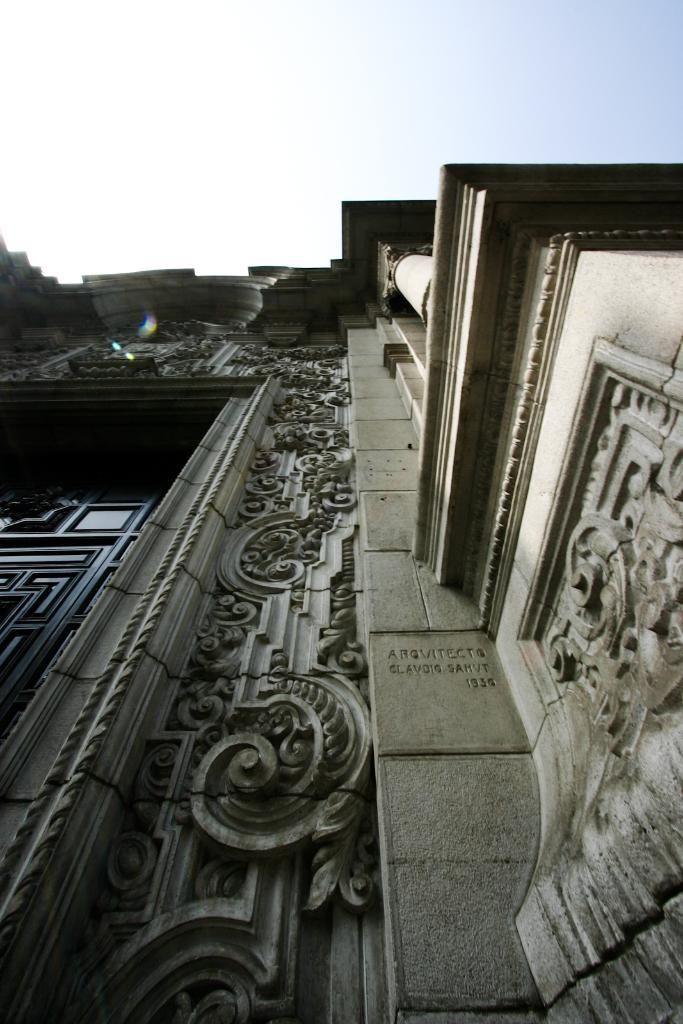What type of structure is present in the image? There is a building in the image. What can be seen in the background of the image? The sky is visible in the background of the image. What type of lunch is being served in the image? There is no lunch present in the image; it only features a building and the sky. 